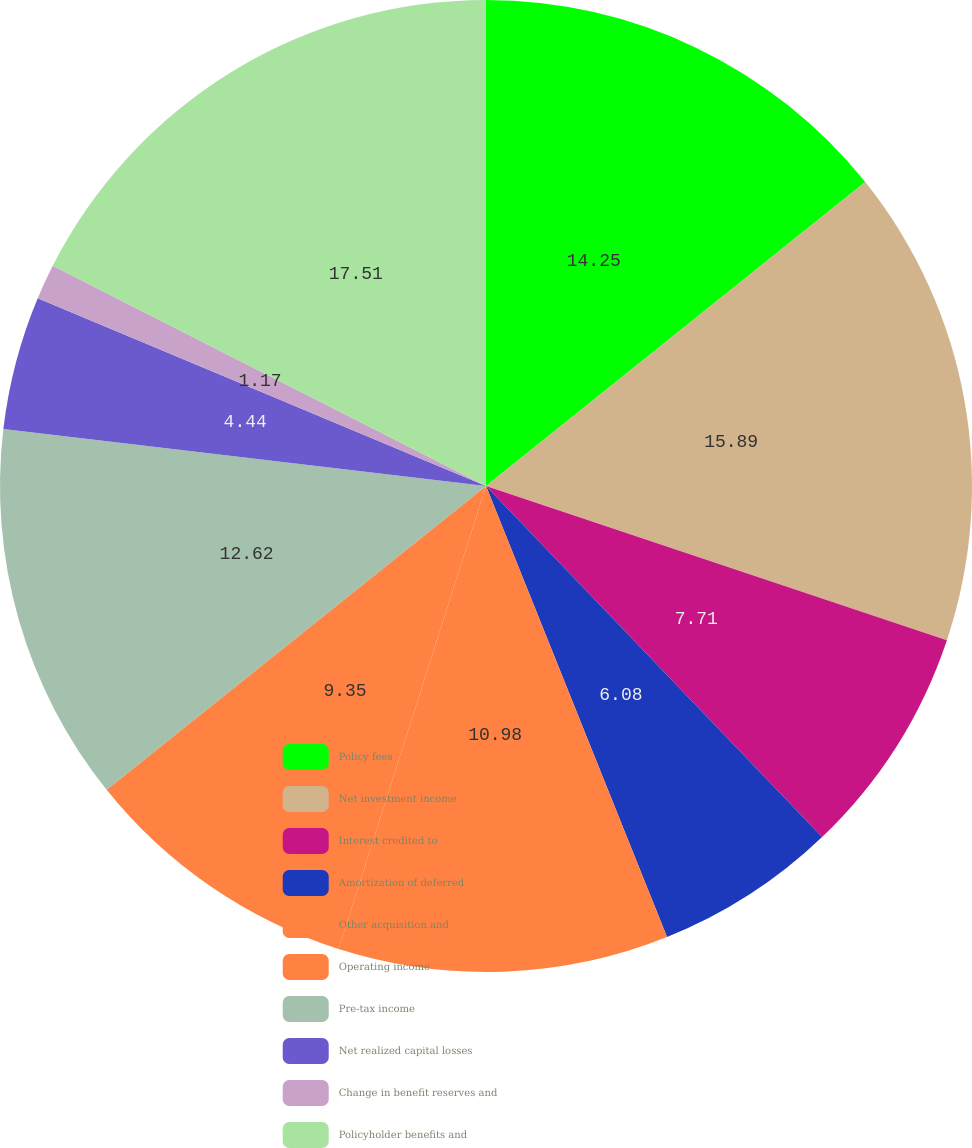<chart> <loc_0><loc_0><loc_500><loc_500><pie_chart><fcel>Policy fees<fcel>Net investment income<fcel>Interest credited to<fcel>Amortization of deferred<fcel>Other acquisition and<fcel>Operating income<fcel>Pre-tax income<fcel>Net realized capital losses<fcel>Change in benefit reserves and<fcel>Policyholder benefits and<nl><fcel>14.25%<fcel>15.89%<fcel>7.71%<fcel>6.08%<fcel>10.98%<fcel>9.35%<fcel>12.62%<fcel>4.44%<fcel>1.17%<fcel>17.52%<nl></chart> 